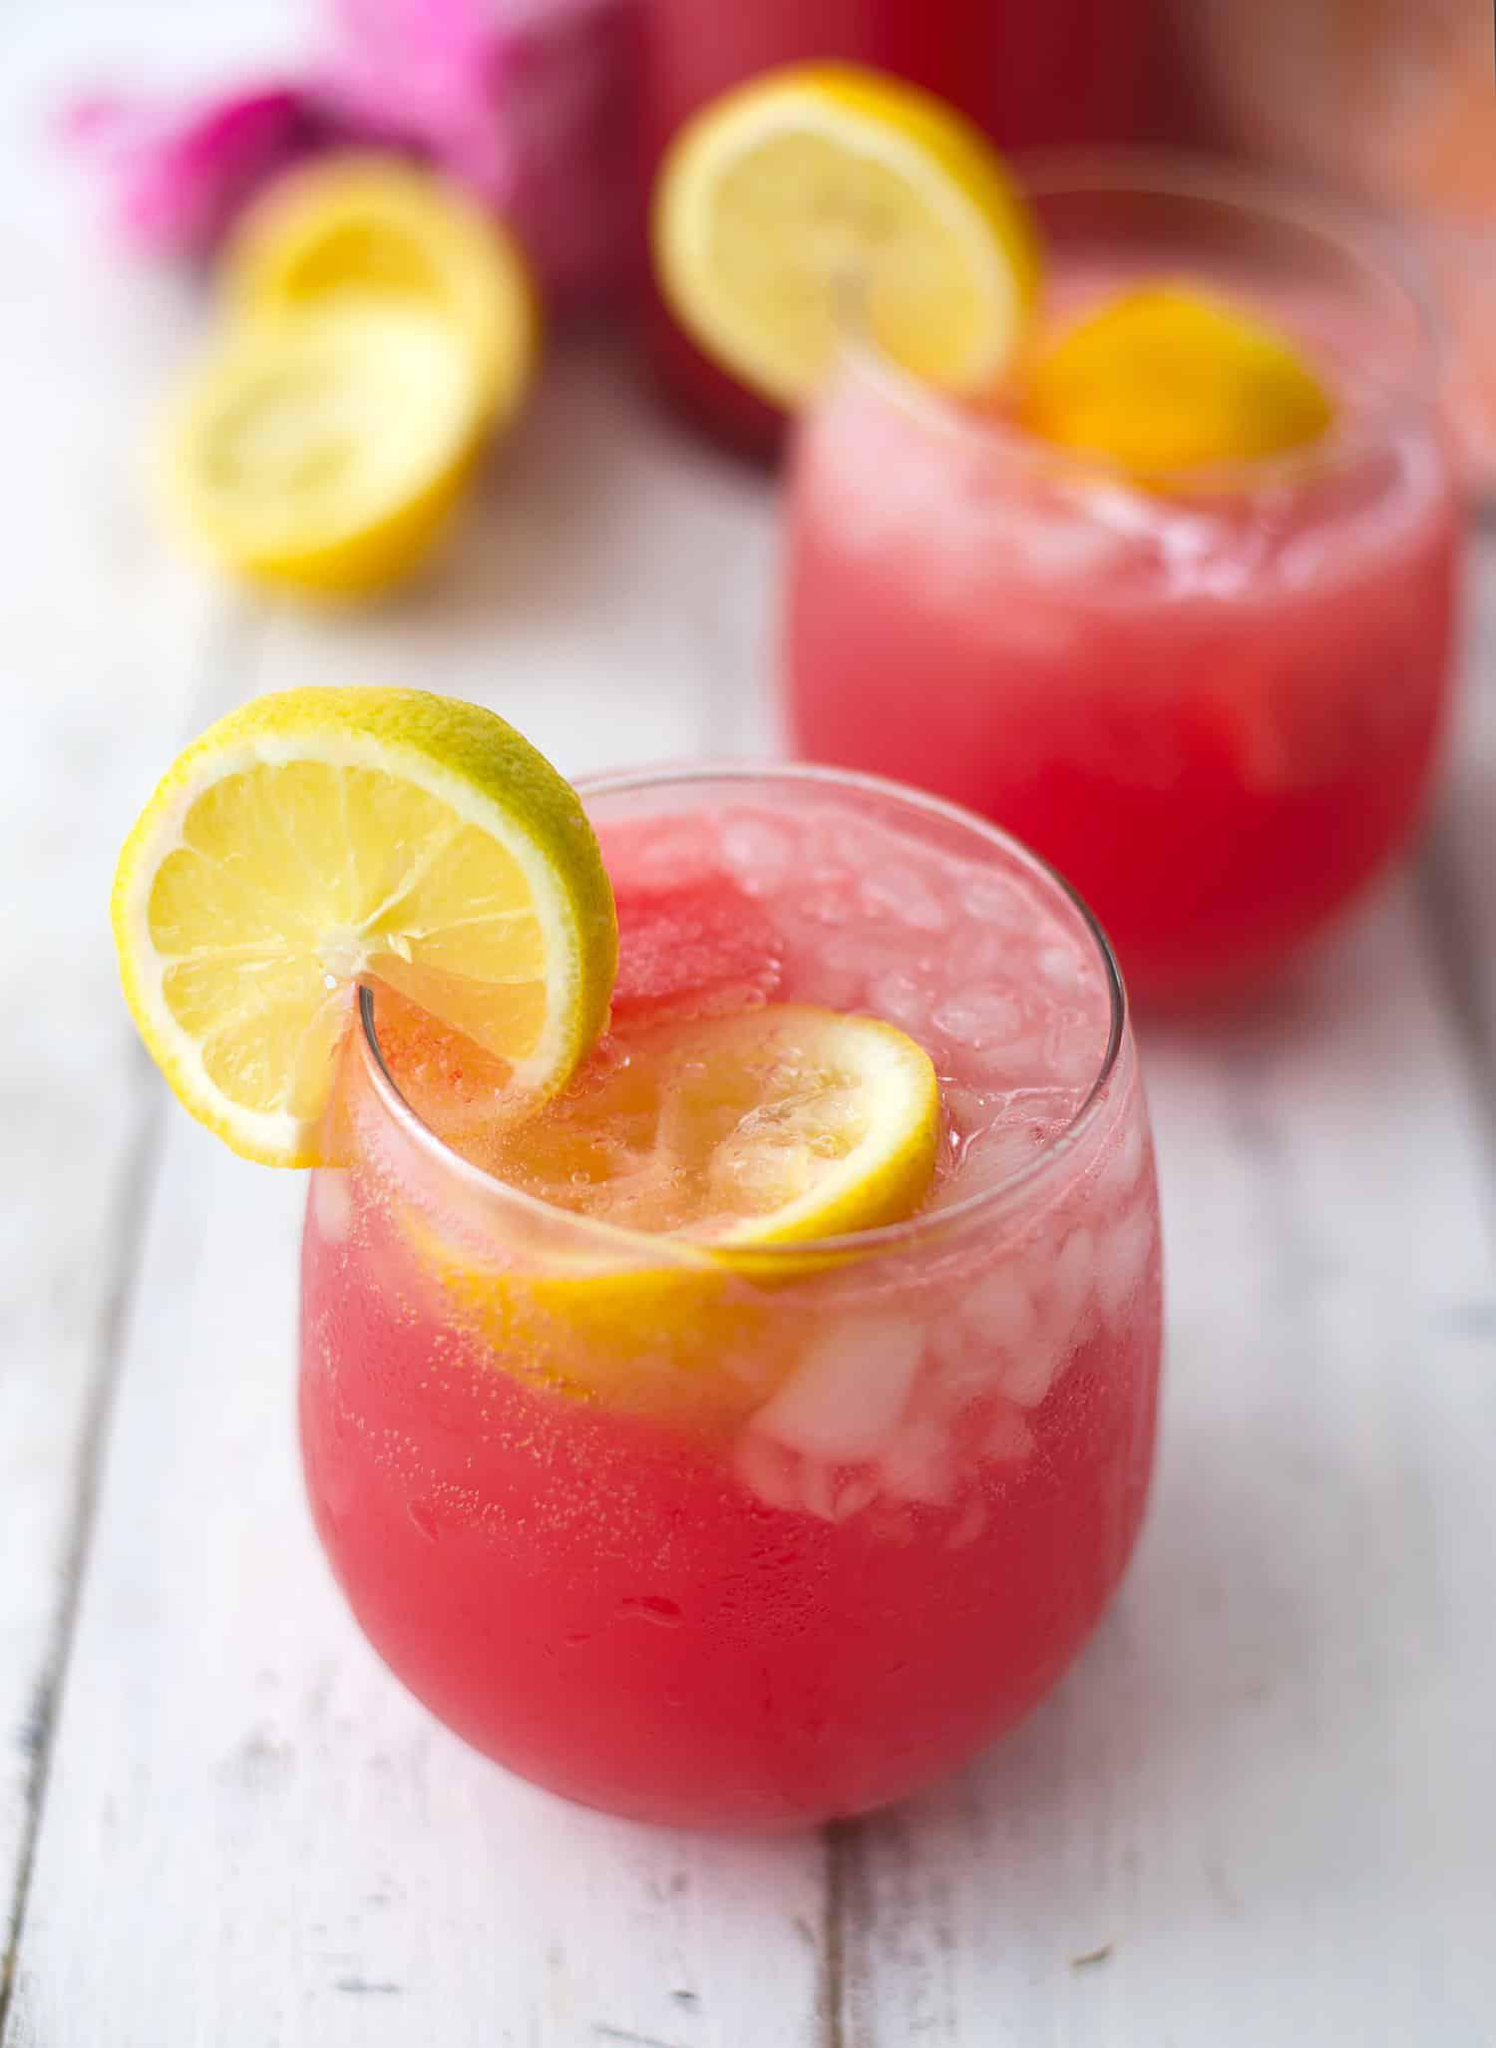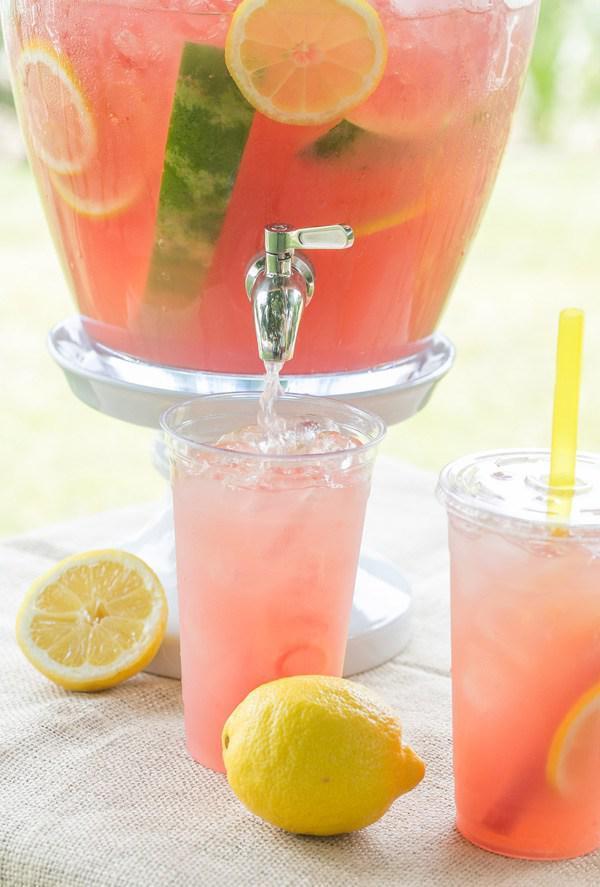The first image is the image on the left, the second image is the image on the right. Assess this claim about the two images: "Fruity drinks are garnished with fruit and striped straws.". Correct or not? Answer yes or no. No. The first image is the image on the left, the second image is the image on the right. For the images shown, is this caption "All the images show drinks with straws in them." true? Answer yes or no. No. 